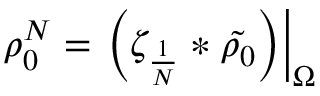Convert formula to latex. <formula><loc_0><loc_0><loc_500><loc_500>\rho _ { 0 } ^ { N } = \left ( \zeta _ { \frac { 1 } { N } } * \tilde { \rho _ { 0 } } \right ) \right | _ { \Omega }</formula> 